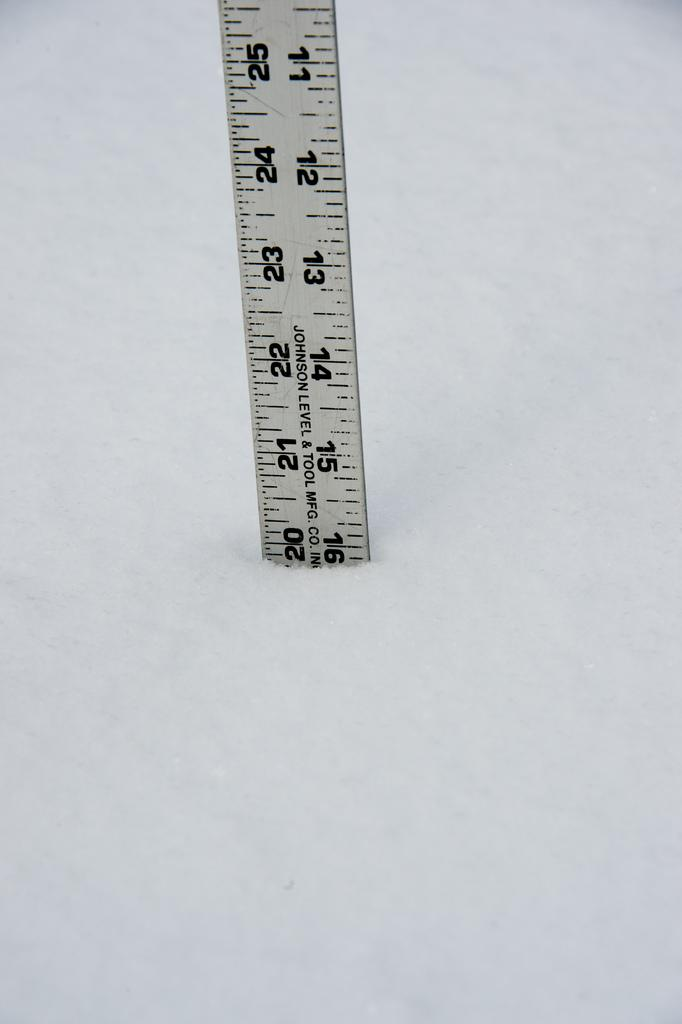<image>
Summarize the visual content of the image. A yard stick labeled Johnson Level & Tool Mfg. Co. is standing in snow at a depth of almost 20 inches. 